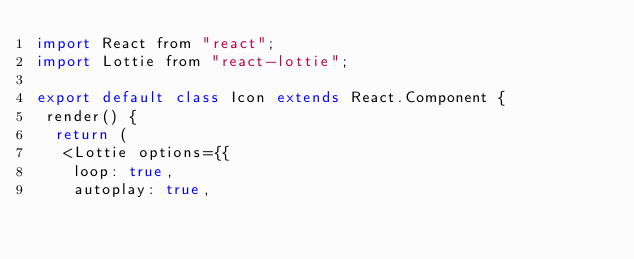Convert code to text. <code><loc_0><loc_0><loc_500><loc_500><_JavaScript_>import React from "react";
import Lottie from "react-lottie";

export default class Icon extends React.Component {
 render() {
  return (
   <Lottie options={{
    loop: true,
    autoplay: true,</code> 